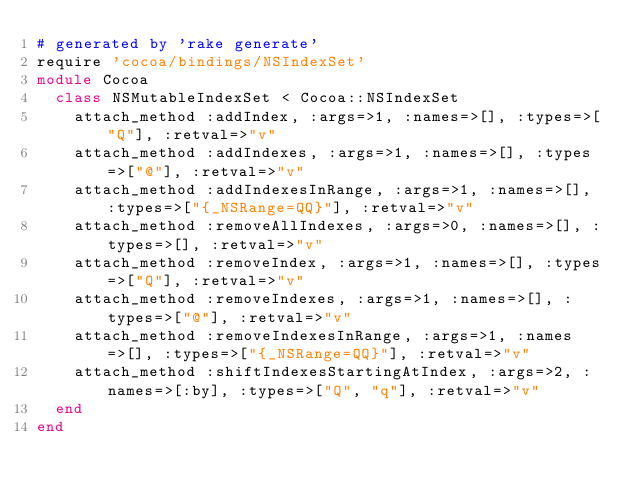<code> <loc_0><loc_0><loc_500><loc_500><_Ruby_># generated by 'rake generate'
require 'cocoa/bindings/NSIndexSet'
module Cocoa
  class NSMutableIndexSet < Cocoa::NSIndexSet
    attach_method :addIndex, :args=>1, :names=>[], :types=>["Q"], :retval=>"v"
    attach_method :addIndexes, :args=>1, :names=>[], :types=>["@"], :retval=>"v"
    attach_method :addIndexesInRange, :args=>1, :names=>[], :types=>["{_NSRange=QQ}"], :retval=>"v"
    attach_method :removeAllIndexes, :args=>0, :names=>[], :types=>[], :retval=>"v"
    attach_method :removeIndex, :args=>1, :names=>[], :types=>["Q"], :retval=>"v"
    attach_method :removeIndexes, :args=>1, :names=>[], :types=>["@"], :retval=>"v"
    attach_method :removeIndexesInRange, :args=>1, :names=>[], :types=>["{_NSRange=QQ}"], :retval=>"v"
    attach_method :shiftIndexesStartingAtIndex, :args=>2, :names=>[:by], :types=>["Q", "q"], :retval=>"v"
  end
end
</code> 